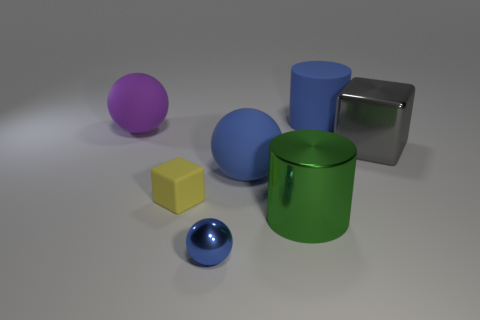What can you tell me about the texture and material of the objects in the image? The objects in the image display a variety of textures and possible materials. The large gray and small blue objects exhibit a reflective surface, suggesting a smooth texture akin to polished metal or plastic. The green container and blue cylinder have a matte finish, indicating a surface that might be less smooth, commonly seen in painted metal or dense plastic. The yellow cube and purple ball seem to have an even, non-reflective surface, possibly indicative of a softer material like rubber or matte plastic. 